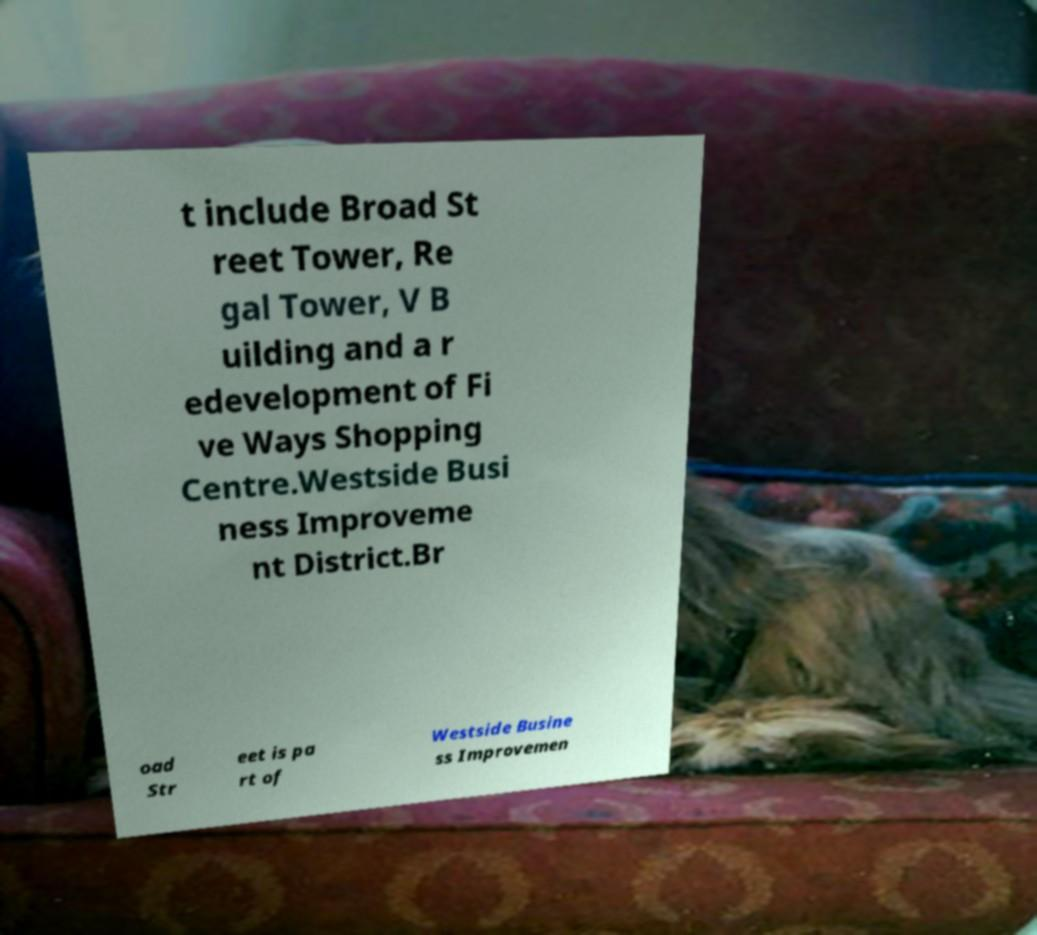Can you read and provide the text displayed in the image?This photo seems to have some interesting text. Can you extract and type it out for me? t include Broad St reet Tower, Re gal Tower, V B uilding and a r edevelopment of Fi ve Ways Shopping Centre.Westside Busi ness Improveme nt District.Br oad Str eet is pa rt of Westside Busine ss Improvemen 